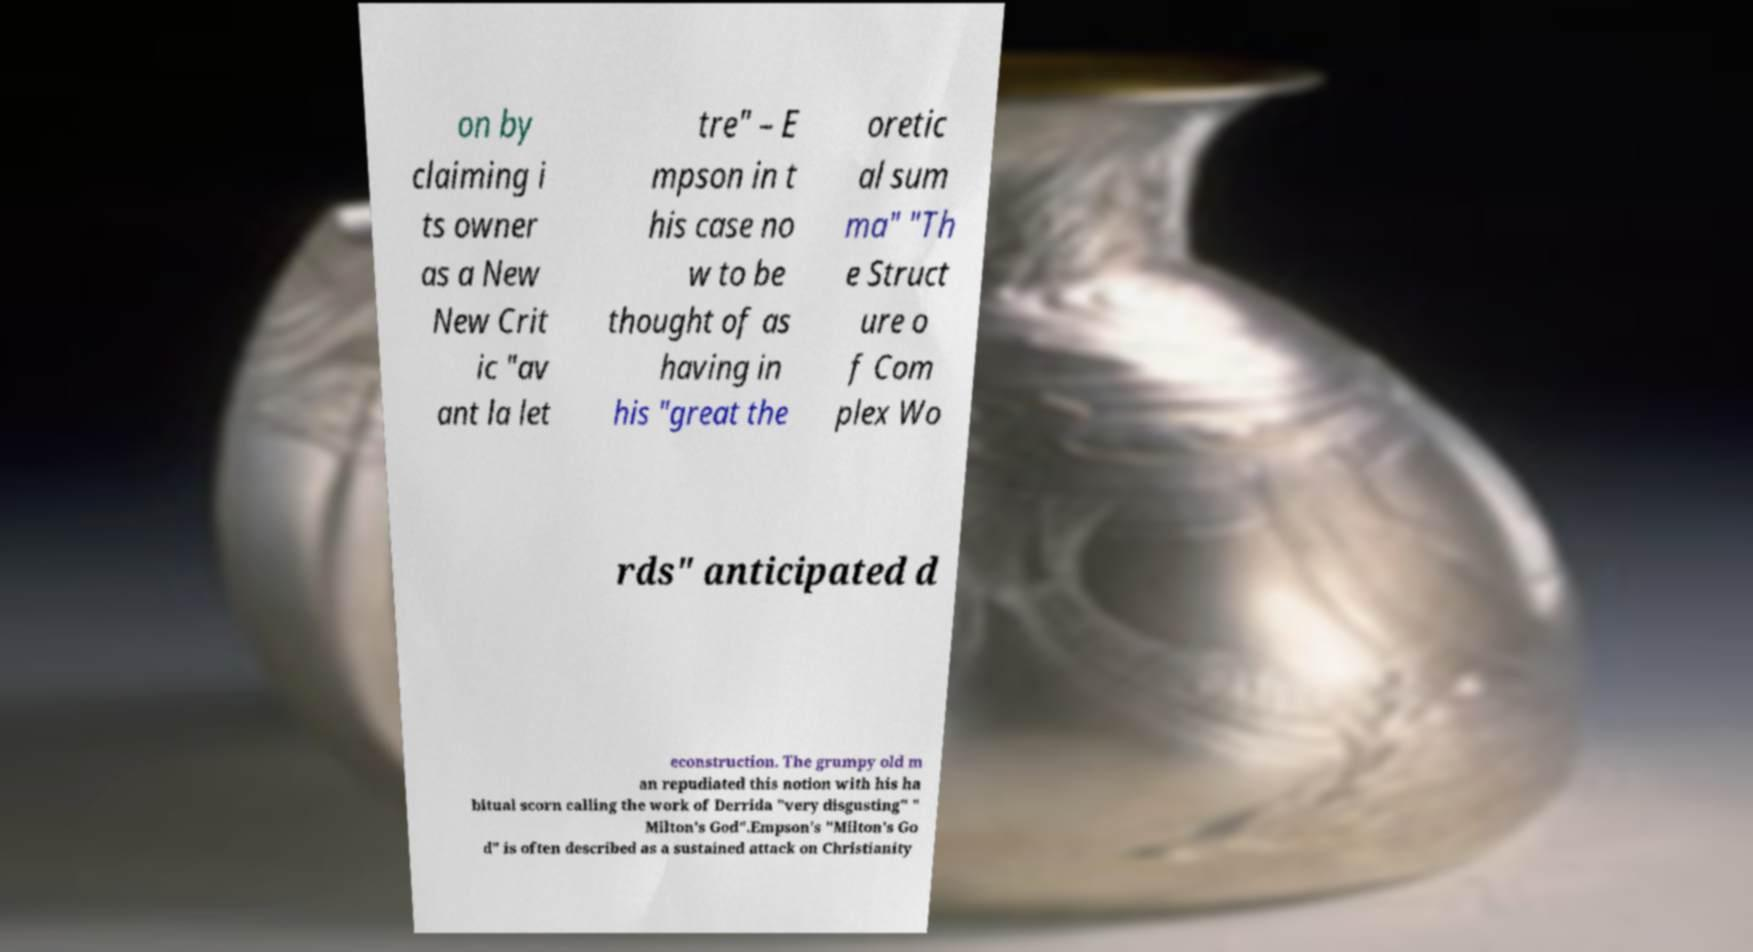There's text embedded in this image that I need extracted. Can you transcribe it verbatim? on by claiming i ts owner as a New New Crit ic "av ant la let tre" – E mpson in t his case no w to be thought of as having in his "great the oretic al sum ma" "Th e Struct ure o f Com plex Wo rds" anticipated d econstruction. The grumpy old m an repudiated this notion with his ha bitual scorn calling the work of Derrida "very disgusting" " Milton's God".Empson's "Milton's Go d" is often described as a sustained attack on Christianity 